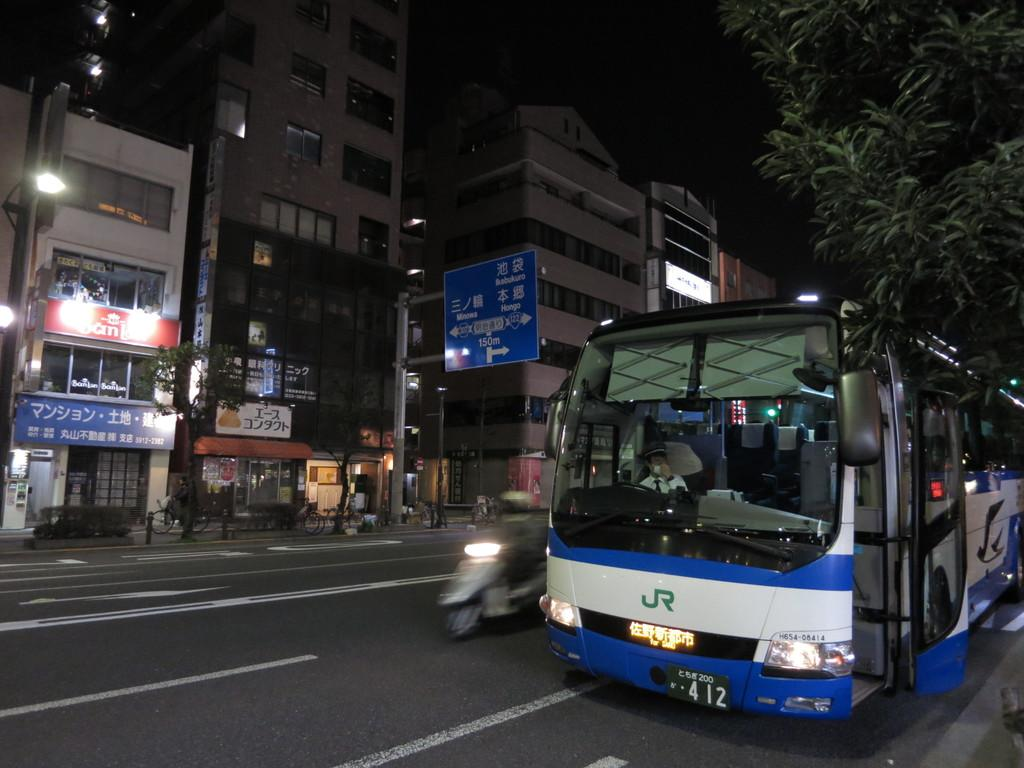What can be seen on the road in the image? There are vehicles on the road in the image. What is visible in the background of the image? There are buildings, trees, lights, and boards in the background of the image. Can you describe the people in the background of the image? There are people in the background of the image. What else can be seen in the image besides the vehicles and people? There are poles in the image. Where is the cactus located in the image? There is no cactus present in the image. What type of pan is being used by the people in the image? There is no pan visible in the image. 